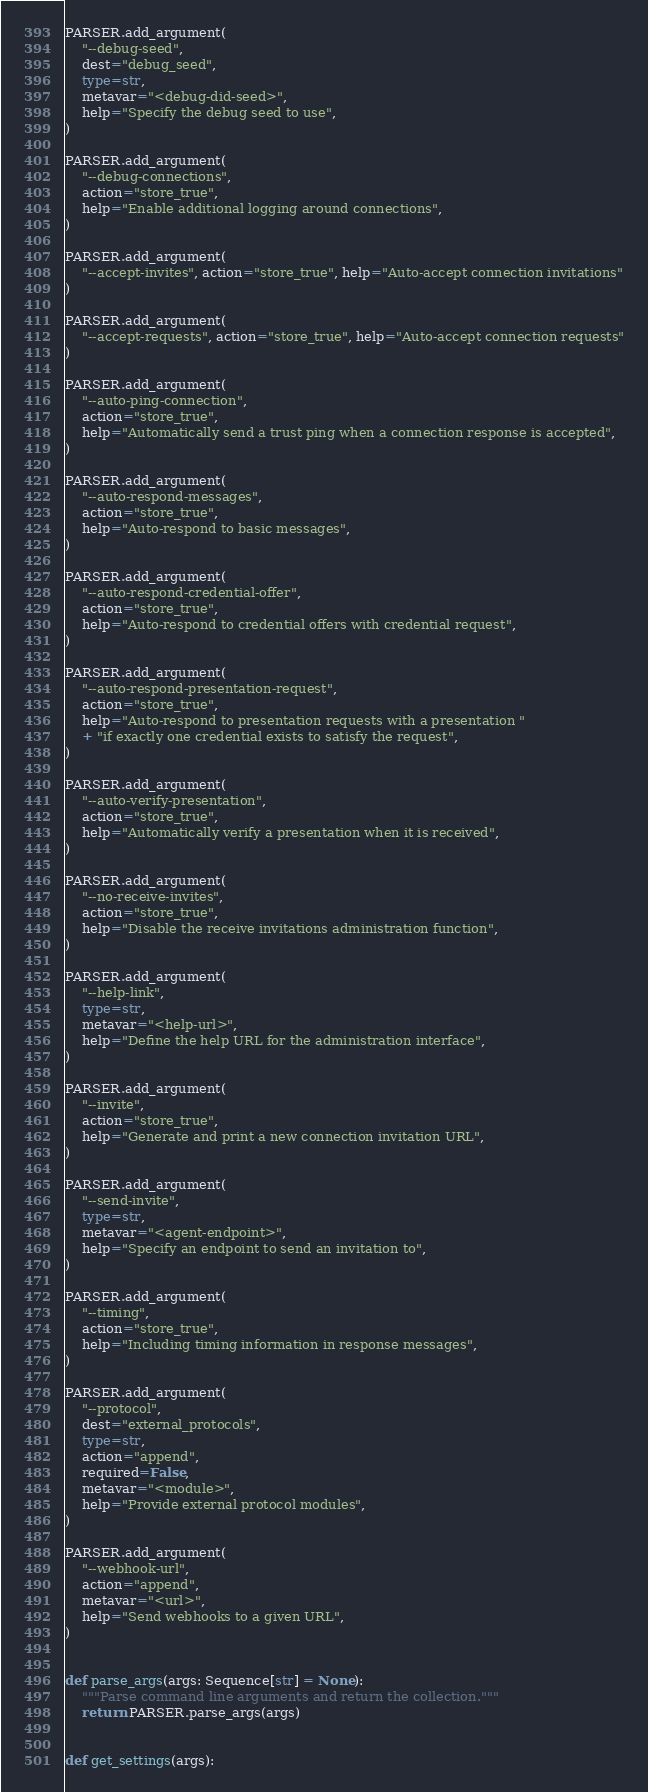<code> <loc_0><loc_0><loc_500><loc_500><_Python_>
PARSER.add_argument(
    "--debug-seed",
    dest="debug_seed",
    type=str,
    metavar="<debug-did-seed>",
    help="Specify the debug seed to use",
)

PARSER.add_argument(
    "--debug-connections",
    action="store_true",
    help="Enable additional logging around connections",
)

PARSER.add_argument(
    "--accept-invites", action="store_true", help="Auto-accept connection invitations"
)

PARSER.add_argument(
    "--accept-requests", action="store_true", help="Auto-accept connection requests"
)

PARSER.add_argument(
    "--auto-ping-connection",
    action="store_true",
    help="Automatically send a trust ping when a connection response is accepted",
)

PARSER.add_argument(
    "--auto-respond-messages",
    action="store_true",
    help="Auto-respond to basic messages",
)

PARSER.add_argument(
    "--auto-respond-credential-offer",
    action="store_true",
    help="Auto-respond to credential offers with credential request",
)

PARSER.add_argument(
    "--auto-respond-presentation-request",
    action="store_true",
    help="Auto-respond to presentation requests with a presentation "
    + "if exactly one credential exists to satisfy the request",
)

PARSER.add_argument(
    "--auto-verify-presentation",
    action="store_true",
    help="Automatically verify a presentation when it is received",
)

PARSER.add_argument(
    "--no-receive-invites",
    action="store_true",
    help="Disable the receive invitations administration function",
)

PARSER.add_argument(
    "--help-link",
    type=str,
    metavar="<help-url>",
    help="Define the help URL for the administration interface",
)

PARSER.add_argument(
    "--invite",
    action="store_true",
    help="Generate and print a new connection invitation URL",
)

PARSER.add_argument(
    "--send-invite",
    type=str,
    metavar="<agent-endpoint>",
    help="Specify an endpoint to send an invitation to",
)

PARSER.add_argument(
    "--timing",
    action="store_true",
    help="Including timing information in response messages",
)

PARSER.add_argument(
    "--protocol",
    dest="external_protocols",
    type=str,
    action="append",
    required=False,
    metavar="<module>",
    help="Provide external protocol modules",
)

PARSER.add_argument(
    "--webhook-url",
    action="append",
    metavar="<url>",
    help="Send webhooks to a given URL",
)


def parse_args(args: Sequence[str] = None):
    """Parse command line arguments and return the collection."""
    return PARSER.parse_args(args)


def get_settings(args):</code> 